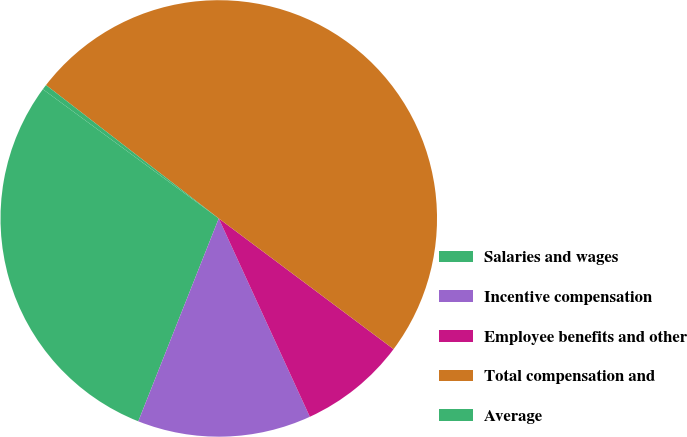Convert chart. <chart><loc_0><loc_0><loc_500><loc_500><pie_chart><fcel>Salaries and wages<fcel>Incentive compensation<fcel>Employee benefits and other<fcel>Total compensation and<fcel>Average<nl><fcel>29.07%<fcel>12.86%<fcel>7.93%<fcel>49.75%<fcel>0.38%<nl></chart> 